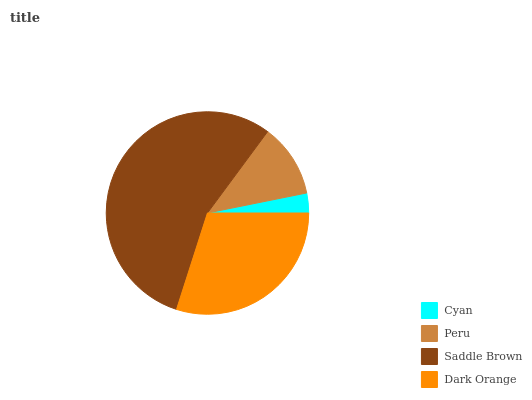Is Cyan the minimum?
Answer yes or no. Yes. Is Saddle Brown the maximum?
Answer yes or no. Yes. Is Peru the minimum?
Answer yes or no. No. Is Peru the maximum?
Answer yes or no. No. Is Peru greater than Cyan?
Answer yes or no. Yes. Is Cyan less than Peru?
Answer yes or no. Yes. Is Cyan greater than Peru?
Answer yes or no. No. Is Peru less than Cyan?
Answer yes or no. No. Is Dark Orange the high median?
Answer yes or no. Yes. Is Peru the low median?
Answer yes or no. Yes. Is Cyan the high median?
Answer yes or no. No. Is Cyan the low median?
Answer yes or no. No. 